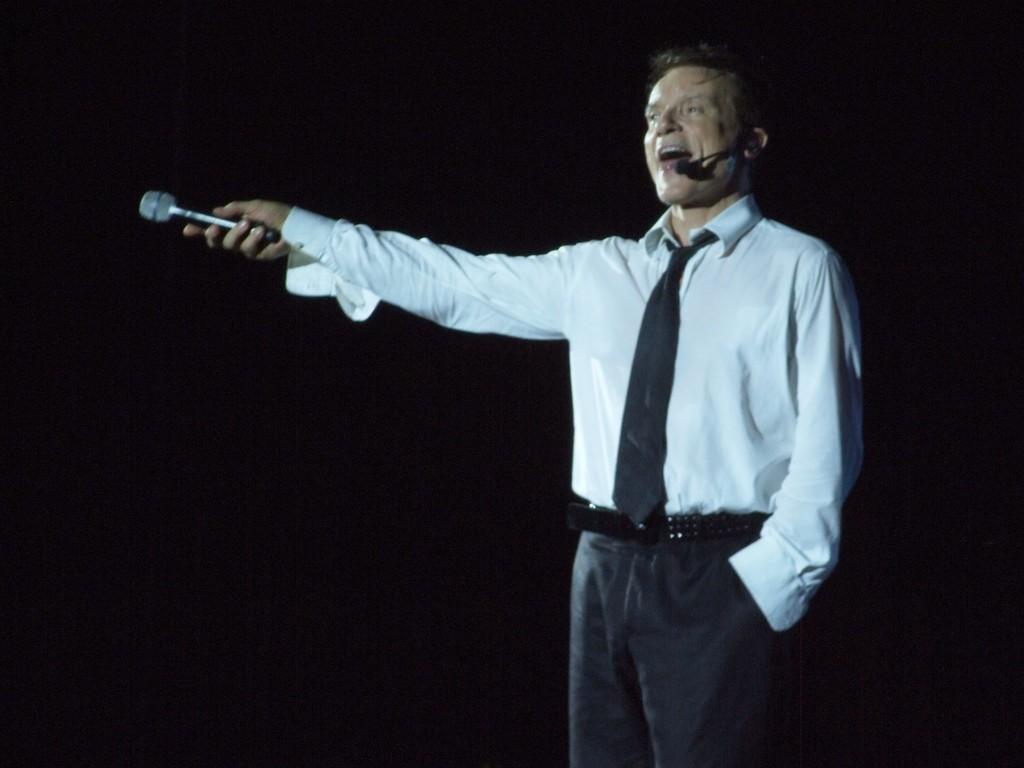Who or what is the main subject of the image? There is a person in the image. What is the person wearing in the image? The person is wearing a mic. What is the person holding in the image? The person is holding a mic. What can be observed about the background of the image? The background of the image is dark. What type of spade can be seen in the image? There is no spade present in the image. Can you provide more details about the fireman in the image? There is no fireman present in the image; the main subject is a person wearing and holding a mic. 